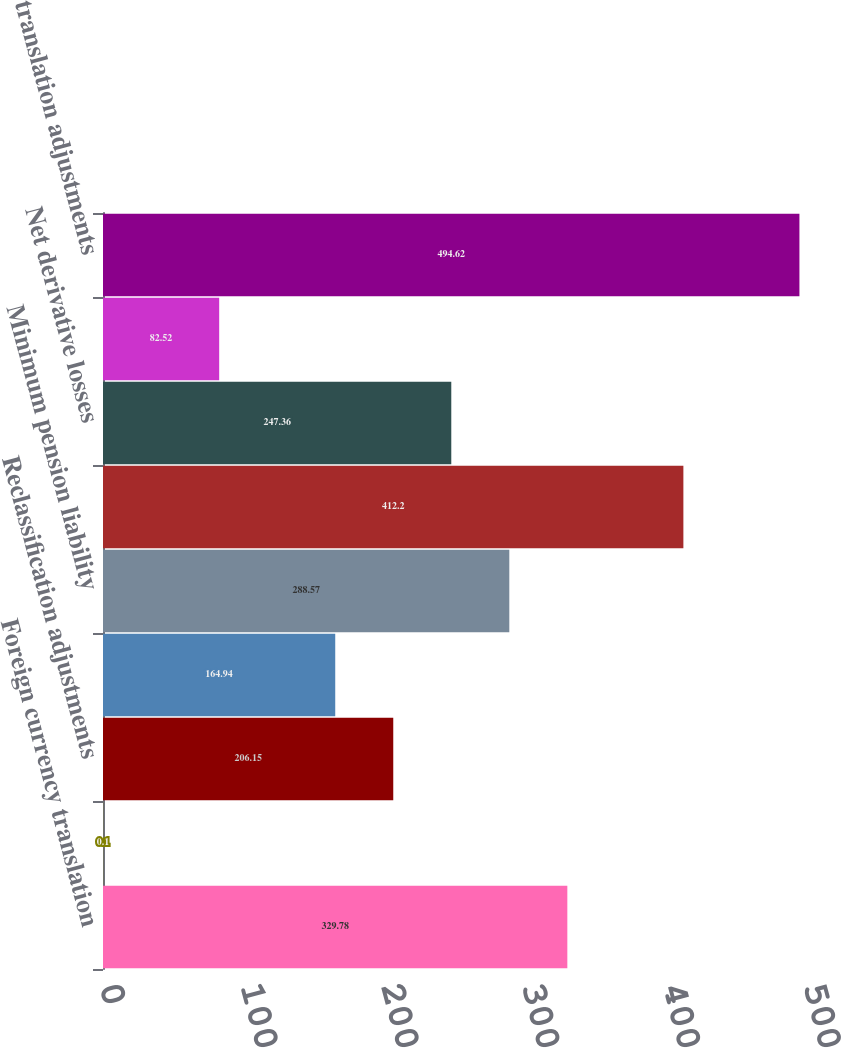Convert chart. <chart><loc_0><loc_0><loc_500><loc_500><bar_chart><fcel>Foreign currency translation<fcel>Net derivative gains<fcel>Reclassification adjustments<fcel>Net loss recognized in other<fcel>Minimum pension liability<fcel>Other comprehensive (loss)<fcel>Net derivative losses<fcel>Pension adjustment Other<fcel>translation adjustments<nl><fcel>329.78<fcel>0.1<fcel>206.15<fcel>164.94<fcel>288.57<fcel>412.2<fcel>247.36<fcel>82.52<fcel>494.62<nl></chart> 